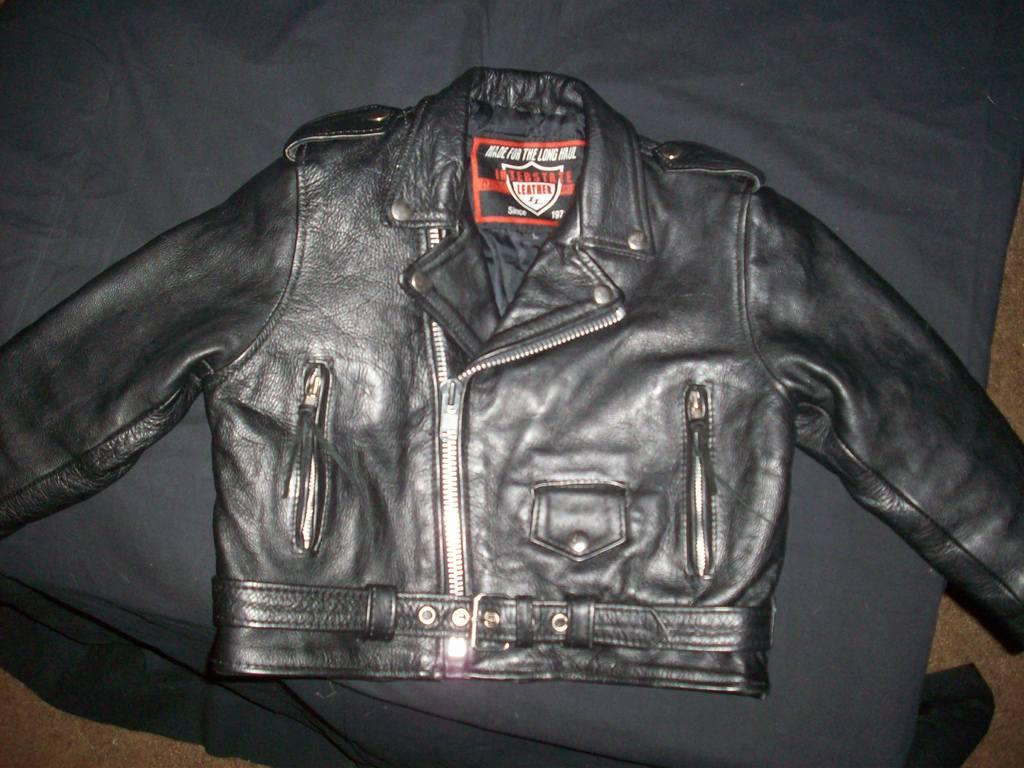What color is the jacket in the image? The jacket in the image is black. Where is the jacket placed in the image? The jacket is on the cloth. What arithmetic problem is being solved on the jacket in the image? There is no arithmetic problem visible on the jacket in the image. How many eggs are present on the jacket in the image? There are no eggs present on the jacket in the image. 